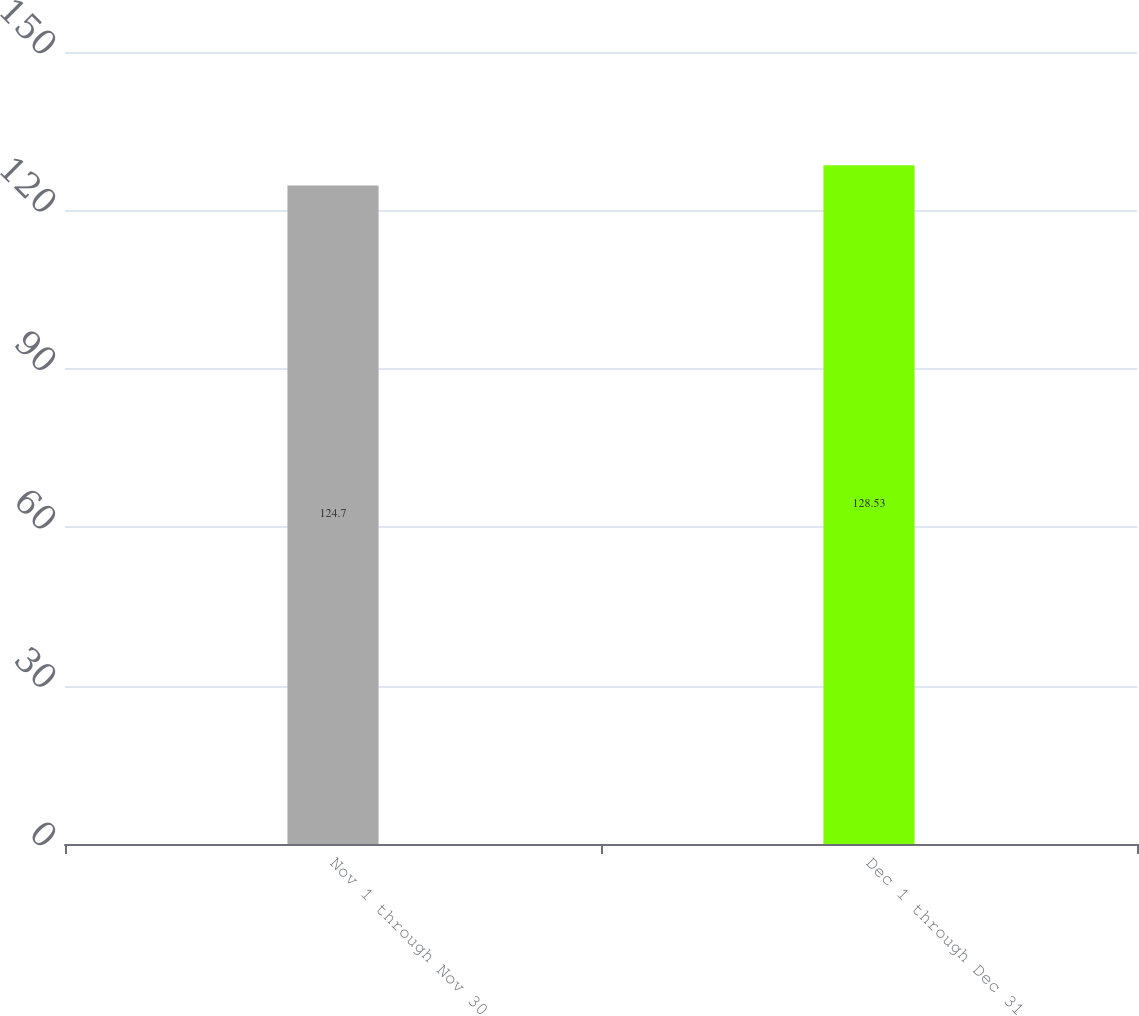<chart> <loc_0><loc_0><loc_500><loc_500><bar_chart><fcel>Nov 1 through Nov 30<fcel>Dec 1 through Dec 31<nl><fcel>124.7<fcel>128.53<nl></chart> 